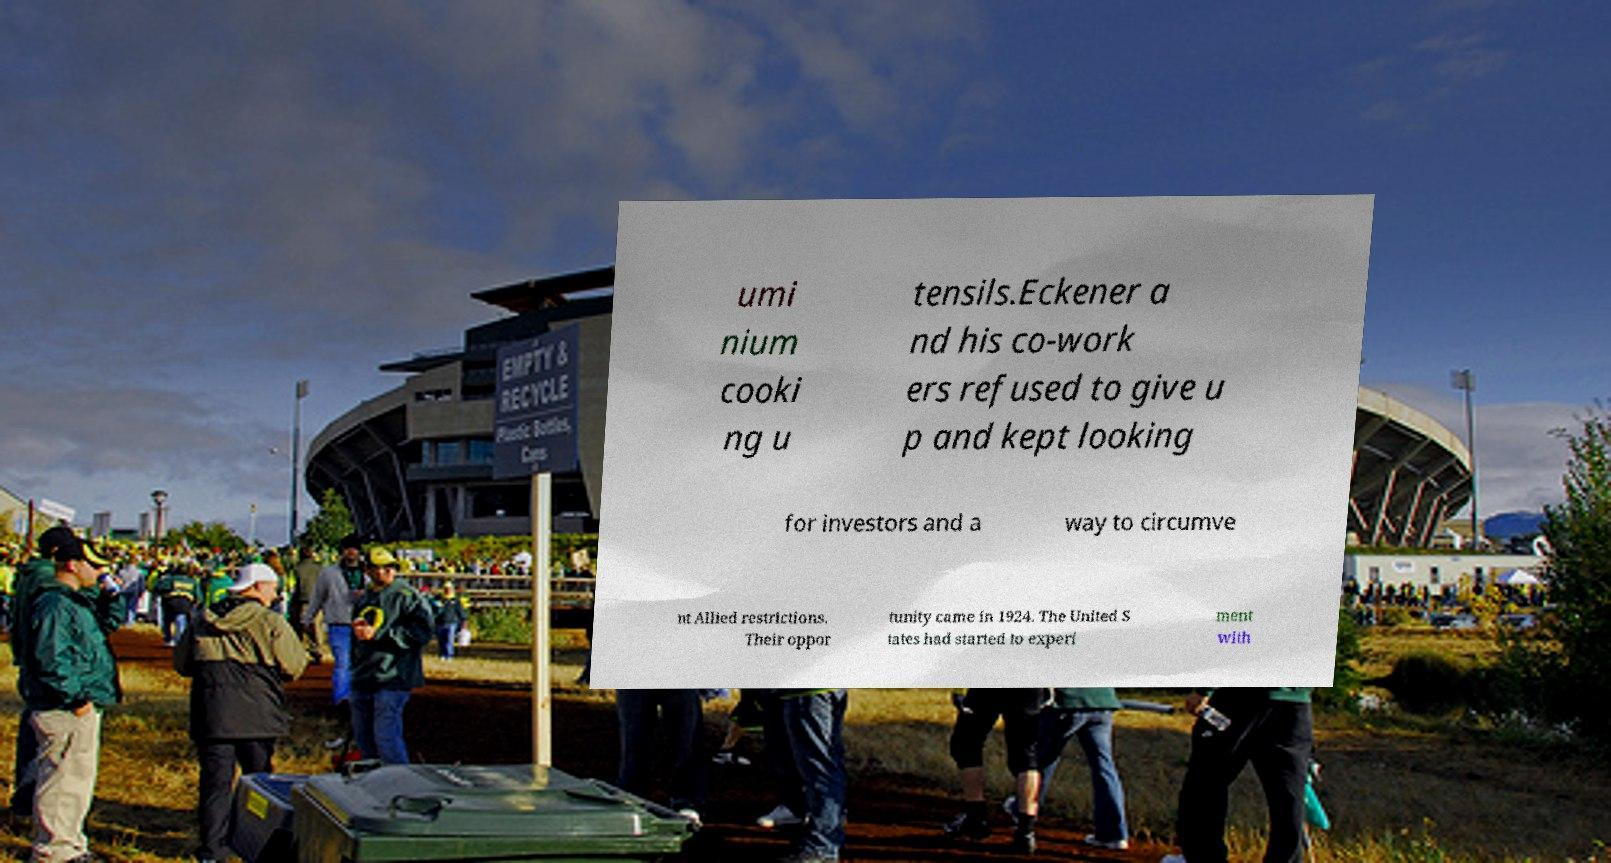I need the written content from this picture converted into text. Can you do that? umi nium cooki ng u tensils.Eckener a nd his co-work ers refused to give u p and kept looking for investors and a way to circumve nt Allied restrictions. Their oppor tunity came in 1924. The United S tates had started to experi ment with 